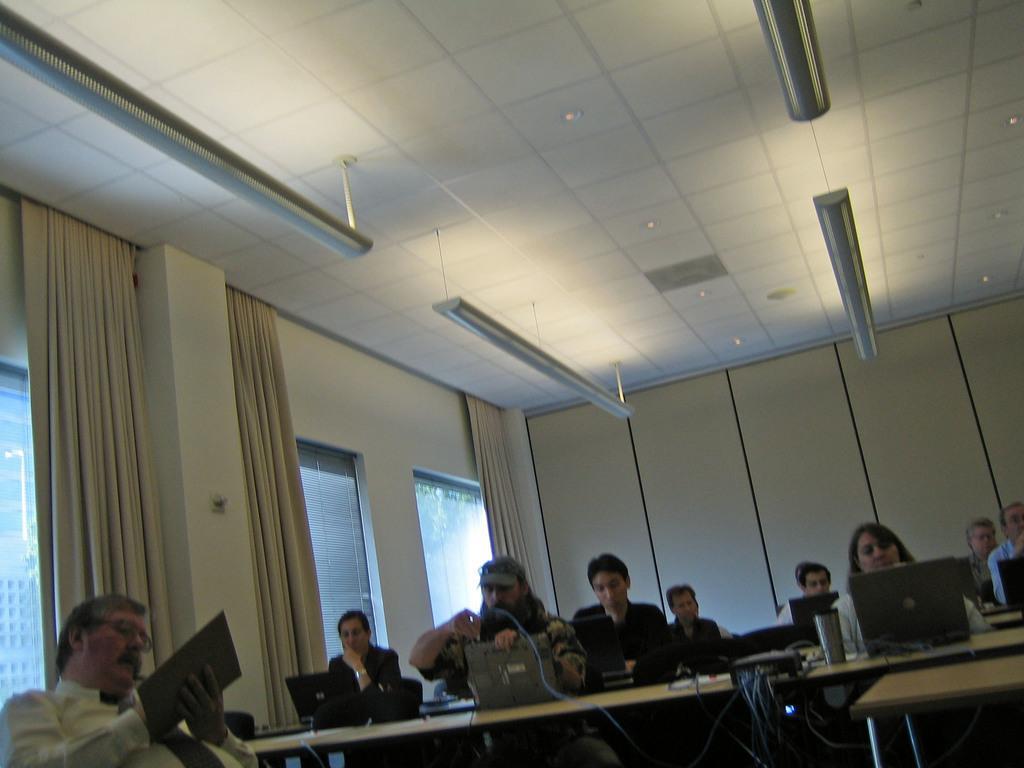Could you give a brief overview of what you see in this image? In this image I can see groups of people sitting, on the left bottom of the image there is a holding a object. On the left side there is a curtain on the walls and glass attached to the wall. Behind the persons they are a wall which is white in color. On the top of the person there is a roof where we can see lights. 